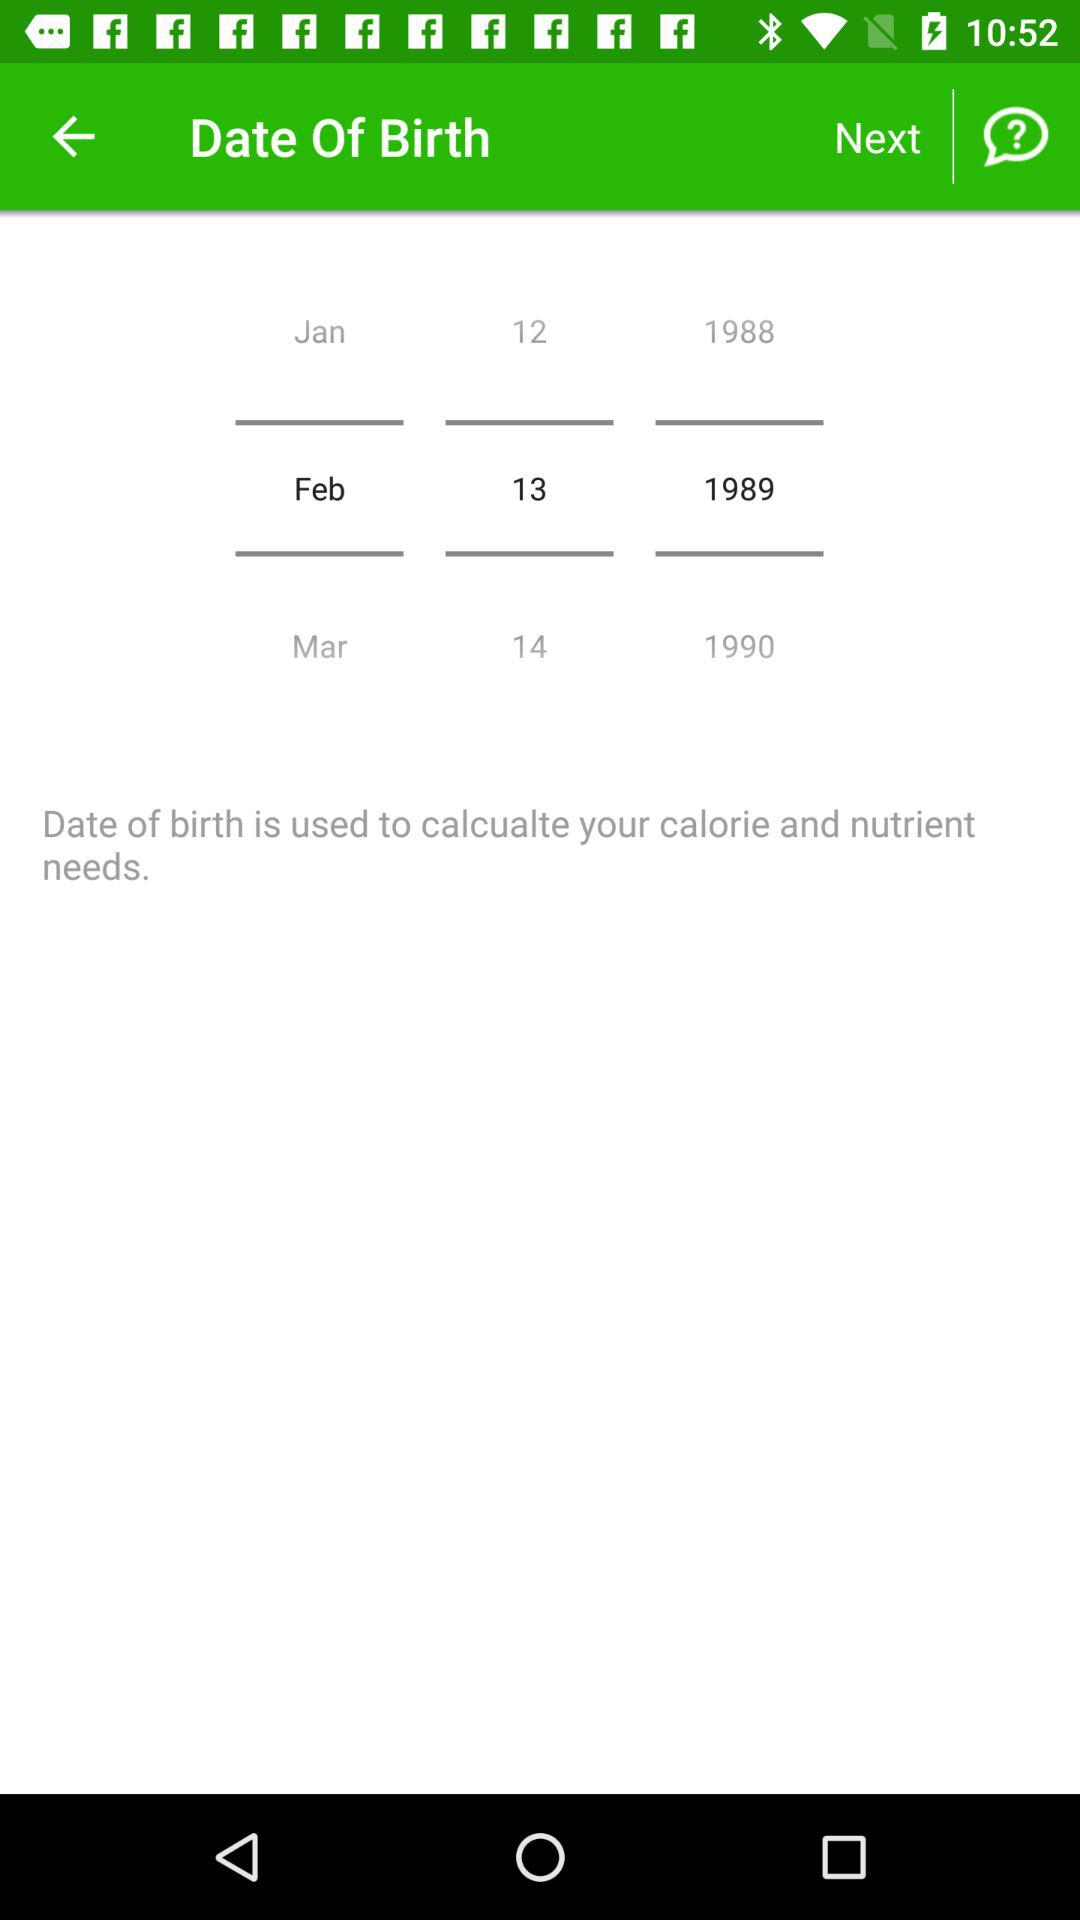What is used to calculate calories and nutrients? To calculate calories and nutrients, the date of birth is used. 